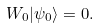<formula> <loc_0><loc_0><loc_500><loc_500>W _ { 0 } | \psi _ { 0 } \rangle = 0 .</formula> 